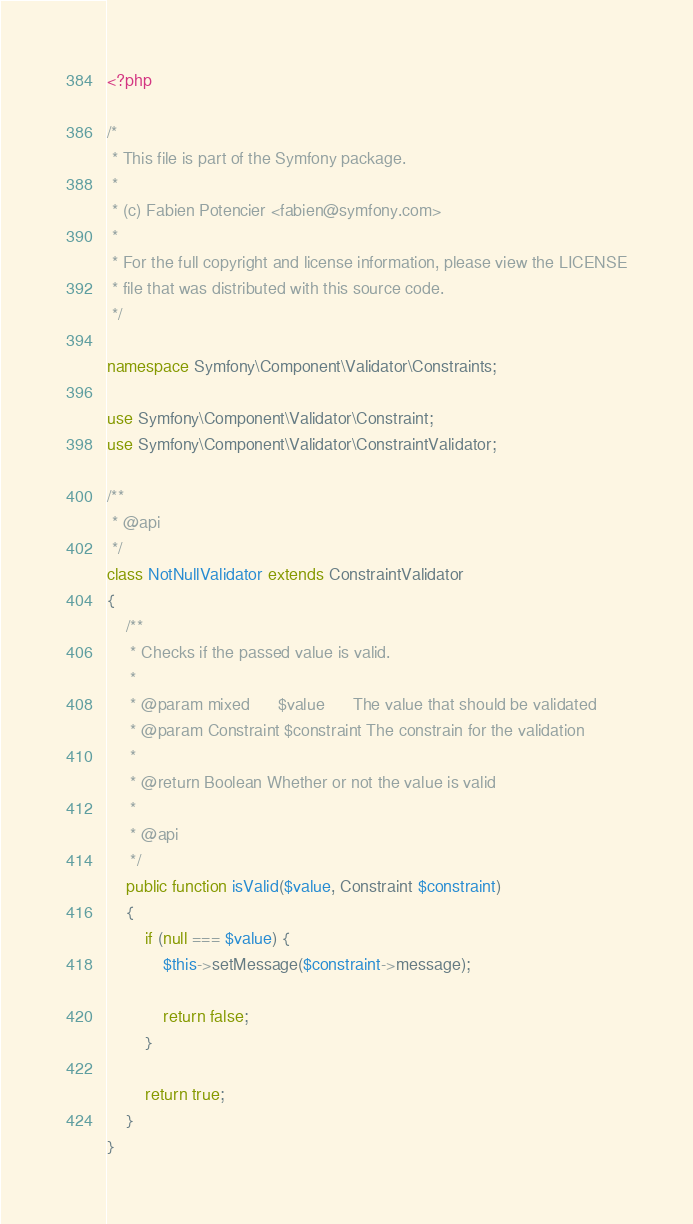Convert code to text. <code><loc_0><loc_0><loc_500><loc_500><_PHP_><?php

/*
 * This file is part of the Symfony package.
 *
 * (c) Fabien Potencier <fabien@symfony.com>
 *
 * For the full copyright and license information, please view the LICENSE
 * file that was distributed with this source code.
 */

namespace Symfony\Component\Validator\Constraints;

use Symfony\Component\Validator\Constraint;
use Symfony\Component\Validator\ConstraintValidator;

/**
 * @api
 */
class NotNullValidator extends ConstraintValidator
{
    /**
     * Checks if the passed value is valid.
     *
     * @param mixed      $value      The value that should be validated
     * @param Constraint $constraint The constrain for the validation
     *
     * @return Boolean Whether or not the value is valid
     *
     * @api
     */
    public function isValid($value, Constraint $constraint)
    {
        if (null === $value) {
            $this->setMessage($constraint->message);

            return false;
        }

        return true;
    }
}
</code> 